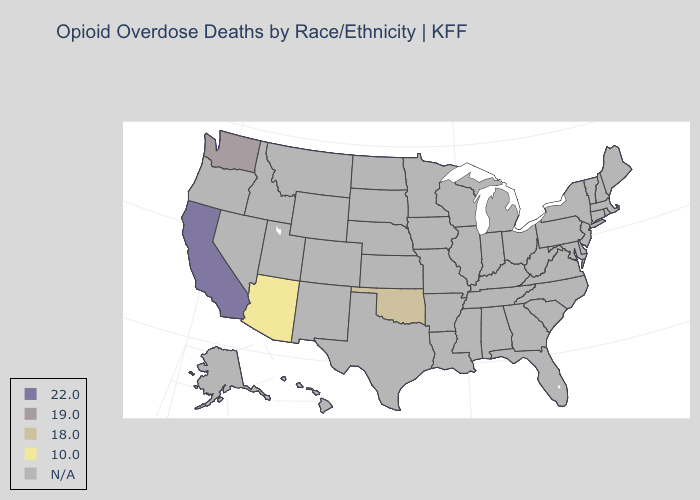What is the value of Alaska?
Give a very brief answer. N/A. Does the map have missing data?
Give a very brief answer. Yes. Which states have the highest value in the USA?
Quick response, please. California. What is the value of Michigan?
Quick response, please. N/A. Which states have the lowest value in the USA?
Keep it brief. Arizona. What is the lowest value in the USA?
Keep it brief. 10.0. Name the states that have a value in the range 18.0?
Write a very short answer. Oklahoma. Does Arizona have the lowest value in the USA?
Be succinct. Yes. Name the states that have a value in the range 22.0?
Be succinct. California. How many symbols are there in the legend?
Concise answer only. 5. Does Washington have the lowest value in the West?
Give a very brief answer. No. 